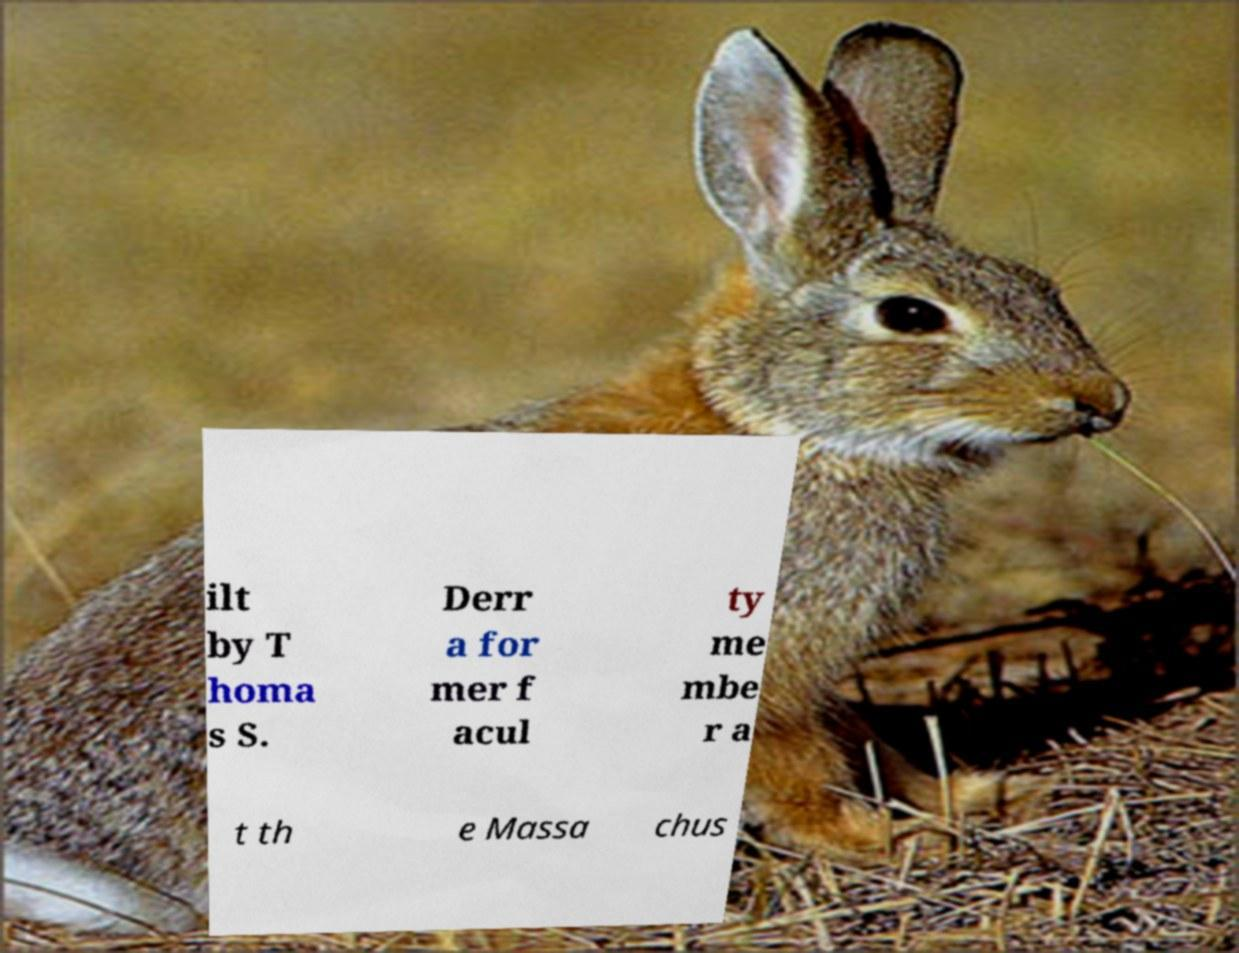Please read and relay the text visible in this image. What does it say? ilt by T homa s S. Derr a for mer f acul ty me mbe r a t th e Massa chus 